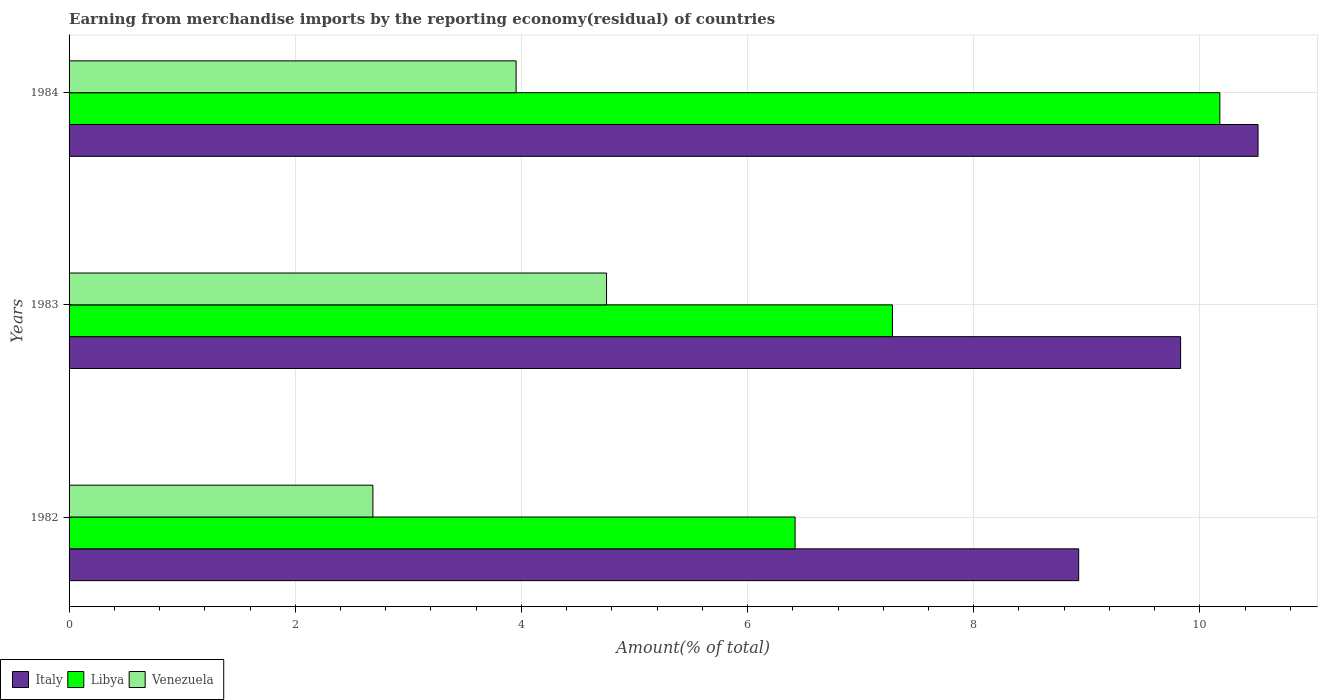How many bars are there on the 1st tick from the top?
Provide a short and direct response. 3. What is the label of the 3rd group of bars from the top?
Provide a short and direct response. 1982. What is the percentage of amount earned from merchandise imports in Libya in 1982?
Give a very brief answer. 6.42. Across all years, what is the maximum percentage of amount earned from merchandise imports in Venezuela?
Your response must be concise. 4.75. Across all years, what is the minimum percentage of amount earned from merchandise imports in Libya?
Make the answer very short. 6.42. In which year was the percentage of amount earned from merchandise imports in Venezuela maximum?
Provide a short and direct response. 1983. What is the total percentage of amount earned from merchandise imports in Italy in the graph?
Your answer should be very brief. 29.27. What is the difference between the percentage of amount earned from merchandise imports in Italy in 1982 and that in 1983?
Provide a succinct answer. -0.9. What is the difference between the percentage of amount earned from merchandise imports in Venezuela in 1983 and the percentage of amount earned from merchandise imports in Italy in 1984?
Keep it short and to the point. -5.76. What is the average percentage of amount earned from merchandise imports in Libya per year?
Offer a very short reply. 7.96. In the year 1984, what is the difference between the percentage of amount earned from merchandise imports in Italy and percentage of amount earned from merchandise imports in Venezuela?
Provide a short and direct response. 6.56. In how many years, is the percentage of amount earned from merchandise imports in Venezuela greater than 0.8 %?
Your answer should be compact. 3. What is the ratio of the percentage of amount earned from merchandise imports in Venezuela in 1983 to that in 1984?
Provide a short and direct response. 1.2. Is the difference between the percentage of amount earned from merchandise imports in Italy in 1983 and 1984 greater than the difference between the percentage of amount earned from merchandise imports in Venezuela in 1983 and 1984?
Offer a very short reply. No. What is the difference between the highest and the second highest percentage of amount earned from merchandise imports in Venezuela?
Your answer should be compact. 0.8. What is the difference between the highest and the lowest percentage of amount earned from merchandise imports in Libya?
Provide a short and direct response. 3.76. Is the sum of the percentage of amount earned from merchandise imports in Italy in 1982 and 1984 greater than the maximum percentage of amount earned from merchandise imports in Libya across all years?
Give a very brief answer. Yes. What does the 2nd bar from the top in 1983 represents?
Make the answer very short. Libya. What does the 3rd bar from the bottom in 1983 represents?
Give a very brief answer. Venezuela. Is it the case that in every year, the sum of the percentage of amount earned from merchandise imports in Libya and percentage of amount earned from merchandise imports in Venezuela is greater than the percentage of amount earned from merchandise imports in Italy?
Offer a very short reply. Yes. How many bars are there?
Your answer should be very brief. 9. Are all the bars in the graph horizontal?
Give a very brief answer. Yes. How many years are there in the graph?
Your answer should be very brief. 3. Where does the legend appear in the graph?
Make the answer very short. Bottom left. How many legend labels are there?
Ensure brevity in your answer.  3. How are the legend labels stacked?
Offer a terse response. Horizontal. What is the title of the graph?
Your response must be concise. Earning from merchandise imports by the reporting economy(residual) of countries. Does "Papua New Guinea" appear as one of the legend labels in the graph?
Make the answer very short. No. What is the label or title of the X-axis?
Your response must be concise. Amount(% of total). What is the Amount(% of total) in Italy in 1982?
Your response must be concise. 8.93. What is the Amount(% of total) of Libya in 1982?
Your answer should be very brief. 6.42. What is the Amount(% of total) in Venezuela in 1982?
Give a very brief answer. 2.69. What is the Amount(% of total) of Italy in 1983?
Offer a very short reply. 9.83. What is the Amount(% of total) of Libya in 1983?
Your answer should be compact. 7.28. What is the Amount(% of total) of Venezuela in 1983?
Make the answer very short. 4.75. What is the Amount(% of total) in Italy in 1984?
Your answer should be compact. 10.51. What is the Amount(% of total) of Libya in 1984?
Keep it short and to the point. 10.18. What is the Amount(% of total) in Venezuela in 1984?
Provide a succinct answer. 3.95. Across all years, what is the maximum Amount(% of total) in Italy?
Ensure brevity in your answer.  10.51. Across all years, what is the maximum Amount(% of total) in Libya?
Your response must be concise. 10.18. Across all years, what is the maximum Amount(% of total) in Venezuela?
Provide a short and direct response. 4.75. Across all years, what is the minimum Amount(% of total) in Italy?
Provide a short and direct response. 8.93. Across all years, what is the minimum Amount(% of total) in Libya?
Your response must be concise. 6.42. Across all years, what is the minimum Amount(% of total) of Venezuela?
Your answer should be compact. 2.69. What is the total Amount(% of total) in Italy in the graph?
Ensure brevity in your answer.  29.27. What is the total Amount(% of total) of Libya in the graph?
Your answer should be compact. 23.88. What is the total Amount(% of total) of Venezuela in the graph?
Offer a terse response. 11.39. What is the difference between the Amount(% of total) in Italy in 1982 and that in 1983?
Offer a very short reply. -0.9. What is the difference between the Amount(% of total) in Libya in 1982 and that in 1983?
Your answer should be very brief. -0.86. What is the difference between the Amount(% of total) of Venezuela in 1982 and that in 1983?
Offer a very short reply. -2.07. What is the difference between the Amount(% of total) of Italy in 1982 and that in 1984?
Give a very brief answer. -1.59. What is the difference between the Amount(% of total) in Libya in 1982 and that in 1984?
Your answer should be compact. -3.76. What is the difference between the Amount(% of total) in Venezuela in 1982 and that in 1984?
Provide a succinct answer. -1.27. What is the difference between the Amount(% of total) of Italy in 1983 and that in 1984?
Your response must be concise. -0.68. What is the difference between the Amount(% of total) of Libya in 1983 and that in 1984?
Your response must be concise. -2.9. What is the difference between the Amount(% of total) in Venezuela in 1983 and that in 1984?
Give a very brief answer. 0.8. What is the difference between the Amount(% of total) in Italy in 1982 and the Amount(% of total) in Libya in 1983?
Keep it short and to the point. 1.65. What is the difference between the Amount(% of total) in Italy in 1982 and the Amount(% of total) in Venezuela in 1983?
Offer a terse response. 4.18. What is the difference between the Amount(% of total) in Libya in 1982 and the Amount(% of total) in Venezuela in 1983?
Your response must be concise. 1.67. What is the difference between the Amount(% of total) of Italy in 1982 and the Amount(% of total) of Libya in 1984?
Your response must be concise. -1.25. What is the difference between the Amount(% of total) of Italy in 1982 and the Amount(% of total) of Venezuela in 1984?
Your answer should be compact. 4.97. What is the difference between the Amount(% of total) of Libya in 1982 and the Amount(% of total) of Venezuela in 1984?
Ensure brevity in your answer.  2.47. What is the difference between the Amount(% of total) of Italy in 1983 and the Amount(% of total) of Libya in 1984?
Give a very brief answer. -0.35. What is the difference between the Amount(% of total) of Italy in 1983 and the Amount(% of total) of Venezuela in 1984?
Your answer should be compact. 5.88. What is the difference between the Amount(% of total) of Libya in 1983 and the Amount(% of total) of Venezuela in 1984?
Provide a short and direct response. 3.33. What is the average Amount(% of total) in Italy per year?
Your answer should be very brief. 9.76. What is the average Amount(% of total) in Libya per year?
Provide a succinct answer. 7.96. What is the average Amount(% of total) in Venezuela per year?
Make the answer very short. 3.8. In the year 1982, what is the difference between the Amount(% of total) of Italy and Amount(% of total) of Libya?
Provide a short and direct response. 2.51. In the year 1982, what is the difference between the Amount(% of total) in Italy and Amount(% of total) in Venezuela?
Offer a very short reply. 6.24. In the year 1982, what is the difference between the Amount(% of total) in Libya and Amount(% of total) in Venezuela?
Your answer should be very brief. 3.73. In the year 1983, what is the difference between the Amount(% of total) in Italy and Amount(% of total) in Libya?
Provide a short and direct response. 2.55. In the year 1983, what is the difference between the Amount(% of total) in Italy and Amount(% of total) in Venezuela?
Make the answer very short. 5.08. In the year 1983, what is the difference between the Amount(% of total) in Libya and Amount(% of total) in Venezuela?
Provide a succinct answer. 2.53. In the year 1984, what is the difference between the Amount(% of total) in Italy and Amount(% of total) in Libya?
Keep it short and to the point. 0.34. In the year 1984, what is the difference between the Amount(% of total) in Italy and Amount(% of total) in Venezuela?
Your answer should be very brief. 6.56. In the year 1984, what is the difference between the Amount(% of total) of Libya and Amount(% of total) of Venezuela?
Your answer should be very brief. 6.22. What is the ratio of the Amount(% of total) of Italy in 1982 to that in 1983?
Provide a succinct answer. 0.91. What is the ratio of the Amount(% of total) of Libya in 1982 to that in 1983?
Offer a terse response. 0.88. What is the ratio of the Amount(% of total) of Venezuela in 1982 to that in 1983?
Ensure brevity in your answer.  0.57. What is the ratio of the Amount(% of total) of Italy in 1982 to that in 1984?
Ensure brevity in your answer.  0.85. What is the ratio of the Amount(% of total) of Libya in 1982 to that in 1984?
Your response must be concise. 0.63. What is the ratio of the Amount(% of total) of Venezuela in 1982 to that in 1984?
Keep it short and to the point. 0.68. What is the ratio of the Amount(% of total) in Italy in 1983 to that in 1984?
Give a very brief answer. 0.93. What is the ratio of the Amount(% of total) of Libya in 1983 to that in 1984?
Offer a terse response. 0.72. What is the ratio of the Amount(% of total) in Venezuela in 1983 to that in 1984?
Offer a terse response. 1.2. What is the difference between the highest and the second highest Amount(% of total) of Italy?
Make the answer very short. 0.68. What is the difference between the highest and the second highest Amount(% of total) in Libya?
Make the answer very short. 2.9. What is the difference between the highest and the second highest Amount(% of total) of Venezuela?
Ensure brevity in your answer.  0.8. What is the difference between the highest and the lowest Amount(% of total) in Italy?
Give a very brief answer. 1.59. What is the difference between the highest and the lowest Amount(% of total) in Libya?
Provide a succinct answer. 3.76. What is the difference between the highest and the lowest Amount(% of total) of Venezuela?
Your response must be concise. 2.07. 